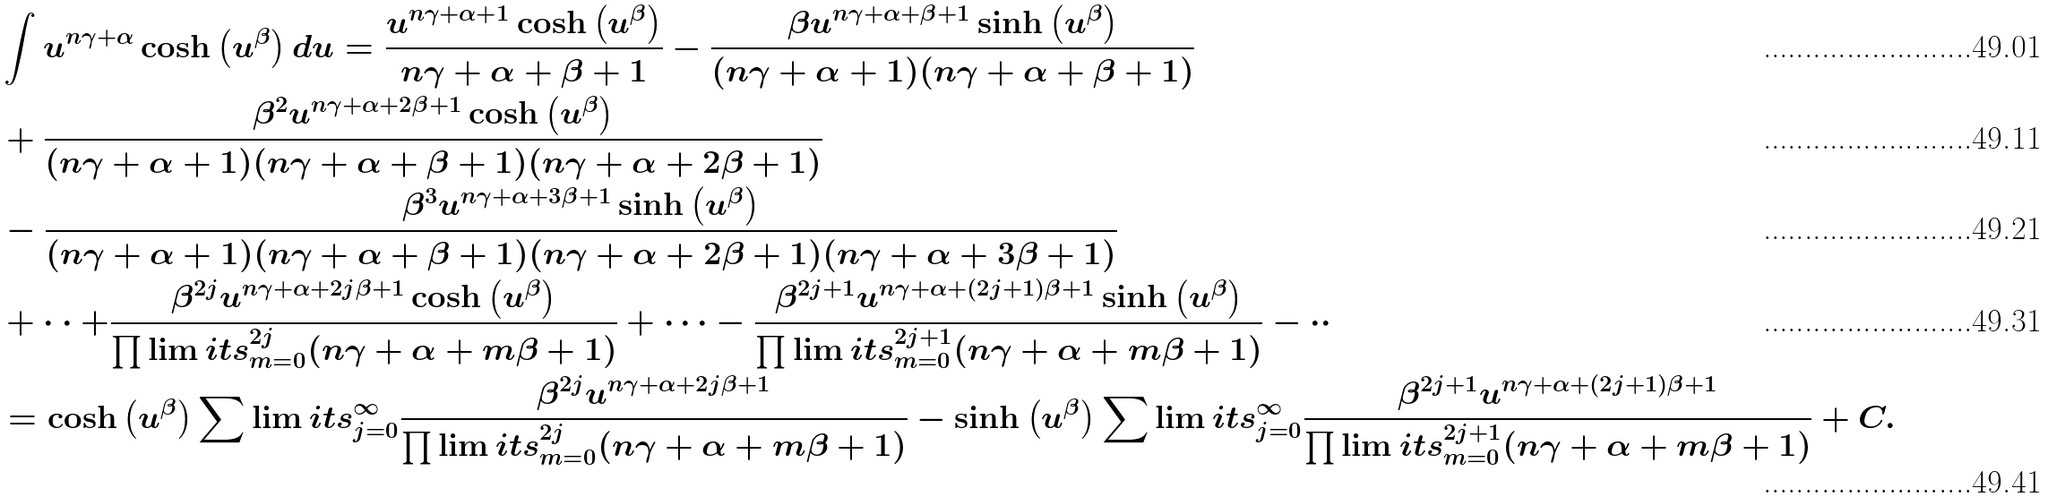<formula> <loc_0><loc_0><loc_500><loc_500>& \int u ^ { n \gamma + \alpha } \cosh \left ( u ^ { \beta } \right ) d u = \frac { u ^ { n \gamma + \alpha + 1 } \cosh \left ( u ^ { \beta } \right ) } { n \gamma + \alpha + \beta + 1 } - \frac { \beta u ^ { n \gamma + \alpha + \beta + 1 } \sinh \left ( u ^ { \beta } \right ) } { ( n \gamma + \alpha + 1 ) ( n \gamma + \alpha + \beta + 1 ) } \\ & + \frac { \beta ^ { 2 } u ^ { n \gamma + \alpha + 2 \beta + 1 } \cosh \left ( u ^ { \beta } \right ) } { ( n \gamma + \alpha + 1 ) ( n \gamma + \alpha + \beta + 1 ) ( n \gamma + \alpha + 2 \beta + 1 ) } \\ & - \frac { \beta ^ { 3 } u ^ { n \gamma + \alpha + 3 \beta + 1 } \sinh \left ( u ^ { \beta } \right ) } { ( n \gamma + \alpha + 1 ) ( n \gamma + \alpha + \beta + 1 ) ( n \gamma + \alpha + 2 \beta + 1 ) ( n \gamma + \alpha + 3 \beta + 1 ) } \\ & + \cdot \cdot + \frac { \beta ^ { 2 j } u ^ { n \gamma + \alpha + 2 j \beta + 1 } \cosh \left ( u ^ { \beta } \right ) } { \prod \lim i t s _ { m = 0 } ^ { 2 j } ( n \gamma + \alpha + m \beta + 1 ) } + \cdots - \frac { \beta ^ { 2 j + 1 } u ^ { n \gamma + \alpha + ( 2 j + 1 ) \beta + 1 } \sinh \left ( u ^ { \beta } \right ) } { \prod \lim i t s _ { m = 0 } ^ { 2 j + 1 } ( n \gamma + \alpha + m \beta + 1 ) } - \cdot \cdot \\ & = \cosh \left ( u ^ { \beta } \right ) \sum \lim i t s _ { j = 0 } ^ { \infty } \frac { \beta ^ { 2 j } u ^ { n \gamma + \alpha + 2 j \beta + 1 } } { \prod \lim i t s _ { m = 0 } ^ { 2 j } ( n \gamma + \alpha + m \beta + 1 ) } - \sinh \left ( u ^ { \beta } \right ) \sum \lim i t s _ { j = 0 } ^ { \infty } \frac { \beta ^ { 2 j + 1 } u ^ { n \gamma + \alpha + ( 2 j + 1 ) \beta + 1 } } { \prod \lim i t s _ { m = 0 } ^ { 2 j + 1 } ( n \gamma + \alpha + m \beta + 1 ) } + C .</formula> 